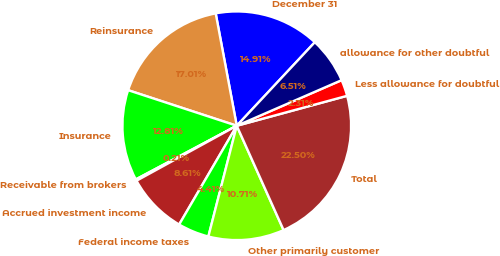Convert chart. <chart><loc_0><loc_0><loc_500><loc_500><pie_chart><fcel>December 31<fcel>Reinsurance<fcel>Insurance<fcel>Receivable from brokers<fcel>Accrued investment income<fcel>Federal income taxes<fcel>Other primarily customer<fcel>Total<fcel>Less allowance for doubtful<fcel>allowance for other doubtful<nl><fcel>14.91%<fcel>17.01%<fcel>12.81%<fcel>0.21%<fcel>8.61%<fcel>4.41%<fcel>10.71%<fcel>22.5%<fcel>2.31%<fcel>6.51%<nl></chart> 